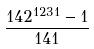Convert formula to latex. <formula><loc_0><loc_0><loc_500><loc_500>\frac { 1 4 2 ^ { 1 2 3 1 } - 1 } { 1 4 1 }</formula> 